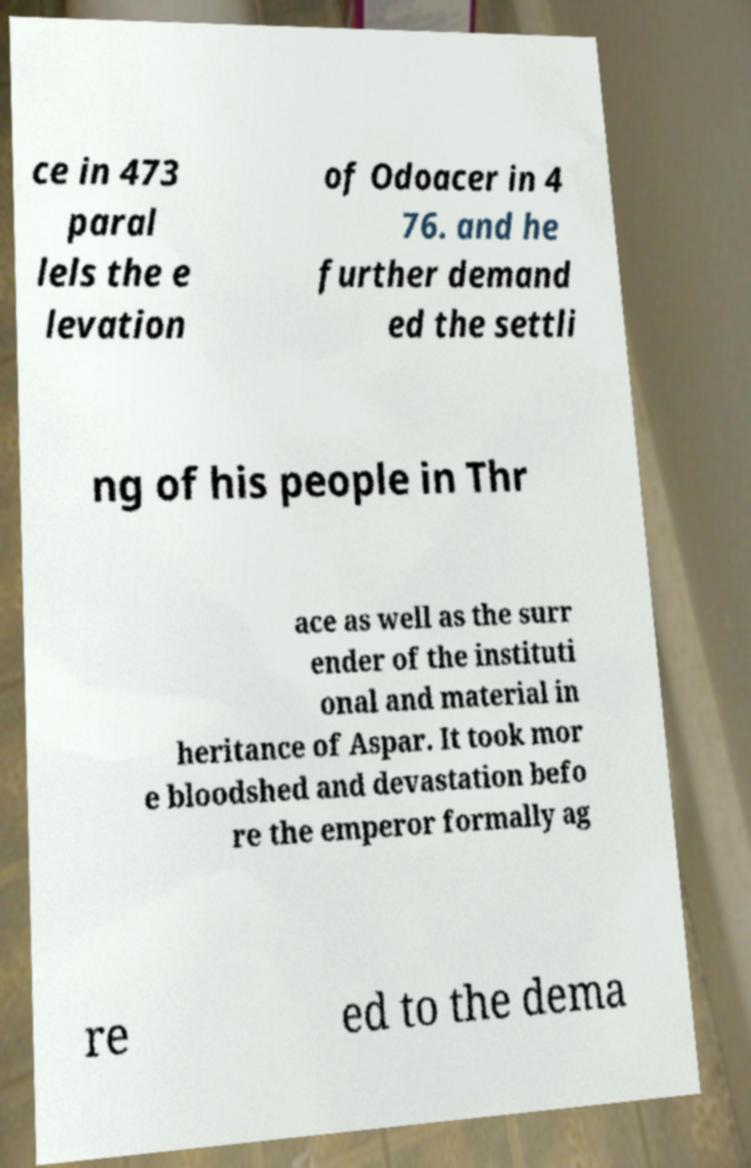Could you extract and type out the text from this image? ce in 473 paral lels the e levation of Odoacer in 4 76. and he further demand ed the settli ng of his people in Thr ace as well as the surr ender of the instituti onal and material in heritance of Aspar. It took mor e bloodshed and devastation befo re the emperor formally ag re ed to the dema 